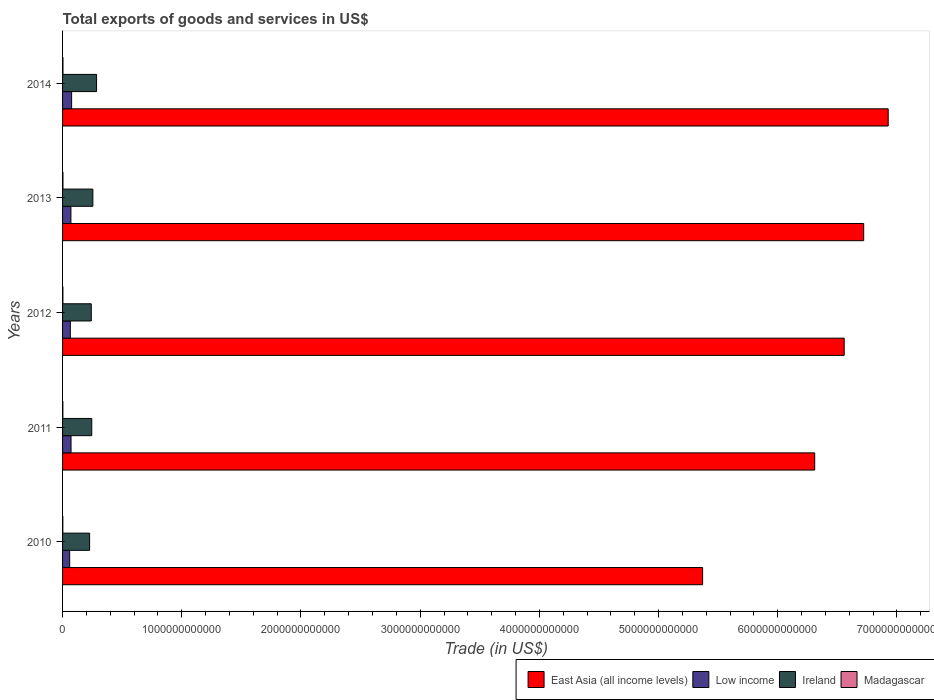How many different coloured bars are there?
Give a very brief answer. 4. How many groups of bars are there?
Give a very brief answer. 5. How many bars are there on the 3rd tick from the bottom?
Make the answer very short. 4. What is the label of the 2nd group of bars from the top?
Offer a terse response. 2013. What is the total exports of goods and services in Madagascar in 2012?
Provide a short and direct response. 2.88e+09. Across all years, what is the maximum total exports of goods and services in Low income?
Make the answer very short. 7.59e+1. Across all years, what is the minimum total exports of goods and services in Low income?
Provide a short and direct response. 5.96e+1. In which year was the total exports of goods and services in Low income maximum?
Provide a short and direct response. 2014. What is the total total exports of goods and services in Low income in the graph?
Offer a terse response. 3.42e+11. What is the difference between the total exports of goods and services in East Asia (all income levels) in 2010 and that in 2013?
Give a very brief answer. -1.35e+12. What is the difference between the total exports of goods and services in Ireland in 2011 and the total exports of goods and services in Low income in 2014?
Ensure brevity in your answer.  1.69e+11. What is the average total exports of goods and services in Ireland per year?
Give a very brief answer. 2.50e+11. In the year 2011, what is the difference between the total exports of goods and services in East Asia (all income levels) and total exports of goods and services in Madagascar?
Provide a short and direct response. 6.31e+12. In how many years, is the total exports of goods and services in Madagascar greater than 5600000000000 US$?
Your answer should be very brief. 0. What is the ratio of the total exports of goods and services in East Asia (all income levels) in 2010 to that in 2011?
Make the answer very short. 0.85. What is the difference between the highest and the second highest total exports of goods and services in Low income?
Your answer should be very brief. 4.85e+09. What is the difference between the highest and the lowest total exports of goods and services in Ireland?
Provide a succinct answer. 5.83e+1. In how many years, is the total exports of goods and services in Ireland greater than the average total exports of goods and services in Ireland taken over all years?
Offer a terse response. 2. Is it the case that in every year, the sum of the total exports of goods and services in Madagascar and total exports of goods and services in Ireland is greater than the sum of total exports of goods and services in East Asia (all income levels) and total exports of goods and services in Low income?
Make the answer very short. Yes. What does the 2nd bar from the top in 2014 represents?
Keep it short and to the point. Ireland. What does the 4th bar from the bottom in 2010 represents?
Give a very brief answer. Madagascar. How many bars are there?
Give a very brief answer. 20. What is the difference between two consecutive major ticks on the X-axis?
Provide a succinct answer. 1.00e+12. Are the values on the major ticks of X-axis written in scientific E-notation?
Your answer should be compact. No. Does the graph contain any zero values?
Keep it short and to the point. No. Does the graph contain grids?
Your answer should be compact. No. How are the legend labels stacked?
Keep it short and to the point. Horizontal. What is the title of the graph?
Make the answer very short. Total exports of goods and services in US$. What is the label or title of the X-axis?
Give a very brief answer. Trade (in US$). What is the label or title of the Y-axis?
Make the answer very short. Years. What is the Trade (in US$) in East Asia (all income levels) in 2010?
Provide a short and direct response. 5.37e+12. What is the Trade (in US$) in Low income in 2010?
Your answer should be very brief. 5.96e+1. What is the Trade (in US$) of Ireland in 2010?
Your response must be concise. 2.27e+11. What is the Trade (in US$) in Madagascar in 2010?
Provide a short and direct response. 2.18e+09. What is the Trade (in US$) of East Asia (all income levels) in 2011?
Your answer should be compact. 6.31e+12. What is the Trade (in US$) in Low income in 2011?
Ensure brevity in your answer.  7.11e+1. What is the Trade (in US$) of Ireland in 2011?
Your answer should be compact. 2.45e+11. What is the Trade (in US$) in Madagascar in 2011?
Offer a terse response. 2.65e+09. What is the Trade (in US$) of East Asia (all income levels) in 2012?
Your response must be concise. 6.56e+12. What is the Trade (in US$) of Low income in 2012?
Make the answer very short. 6.50e+1. What is the Trade (in US$) of Ireland in 2012?
Ensure brevity in your answer.  2.41e+11. What is the Trade (in US$) in Madagascar in 2012?
Give a very brief answer. 2.88e+09. What is the Trade (in US$) of East Asia (all income levels) in 2013?
Offer a very short reply. 6.72e+12. What is the Trade (in US$) in Low income in 2013?
Your answer should be very brief. 7.01e+1. What is the Trade (in US$) in Ireland in 2013?
Your response must be concise. 2.54e+11. What is the Trade (in US$) of Madagascar in 2013?
Offer a terse response. 3.19e+09. What is the Trade (in US$) in East Asia (all income levels) in 2014?
Your response must be concise. 6.93e+12. What is the Trade (in US$) in Low income in 2014?
Provide a succinct answer. 7.59e+1. What is the Trade (in US$) of Ireland in 2014?
Your response must be concise. 2.85e+11. What is the Trade (in US$) of Madagascar in 2014?
Make the answer very short. 3.37e+09. Across all years, what is the maximum Trade (in US$) of East Asia (all income levels)?
Your response must be concise. 6.93e+12. Across all years, what is the maximum Trade (in US$) of Low income?
Your response must be concise. 7.59e+1. Across all years, what is the maximum Trade (in US$) of Ireland?
Ensure brevity in your answer.  2.85e+11. Across all years, what is the maximum Trade (in US$) in Madagascar?
Provide a short and direct response. 3.37e+09. Across all years, what is the minimum Trade (in US$) in East Asia (all income levels)?
Keep it short and to the point. 5.37e+12. Across all years, what is the minimum Trade (in US$) of Low income?
Your answer should be very brief. 5.96e+1. Across all years, what is the minimum Trade (in US$) of Ireland?
Offer a terse response. 2.27e+11. Across all years, what is the minimum Trade (in US$) in Madagascar?
Make the answer very short. 2.18e+09. What is the total Trade (in US$) of East Asia (all income levels) in the graph?
Ensure brevity in your answer.  3.19e+13. What is the total Trade (in US$) of Low income in the graph?
Make the answer very short. 3.42e+11. What is the total Trade (in US$) of Ireland in the graph?
Your answer should be very brief. 1.25e+12. What is the total Trade (in US$) of Madagascar in the graph?
Offer a very short reply. 1.43e+1. What is the difference between the Trade (in US$) of East Asia (all income levels) in 2010 and that in 2011?
Offer a very short reply. -9.40e+11. What is the difference between the Trade (in US$) in Low income in 2010 and that in 2011?
Offer a terse response. -1.15e+1. What is the difference between the Trade (in US$) in Ireland in 2010 and that in 2011?
Offer a very short reply. -1.79e+1. What is the difference between the Trade (in US$) in Madagascar in 2010 and that in 2011?
Ensure brevity in your answer.  -4.65e+08. What is the difference between the Trade (in US$) of East Asia (all income levels) in 2010 and that in 2012?
Make the answer very short. -1.19e+12. What is the difference between the Trade (in US$) in Low income in 2010 and that in 2012?
Keep it short and to the point. -5.43e+09. What is the difference between the Trade (in US$) of Ireland in 2010 and that in 2012?
Provide a succinct answer. -1.39e+1. What is the difference between the Trade (in US$) of Madagascar in 2010 and that in 2012?
Provide a succinct answer. -6.98e+08. What is the difference between the Trade (in US$) in East Asia (all income levels) in 2010 and that in 2013?
Provide a succinct answer. -1.35e+12. What is the difference between the Trade (in US$) of Low income in 2010 and that in 2013?
Your answer should be very brief. -1.06e+1. What is the difference between the Trade (in US$) in Ireland in 2010 and that in 2013?
Ensure brevity in your answer.  -2.72e+1. What is the difference between the Trade (in US$) in Madagascar in 2010 and that in 2013?
Your response must be concise. -1.01e+09. What is the difference between the Trade (in US$) of East Asia (all income levels) in 2010 and that in 2014?
Provide a succinct answer. -1.56e+12. What is the difference between the Trade (in US$) in Low income in 2010 and that in 2014?
Offer a very short reply. -1.64e+1. What is the difference between the Trade (in US$) of Ireland in 2010 and that in 2014?
Provide a succinct answer. -5.83e+1. What is the difference between the Trade (in US$) of Madagascar in 2010 and that in 2014?
Offer a terse response. -1.19e+09. What is the difference between the Trade (in US$) of East Asia (all income levels) in 2011 and that in 2012?
Offer a very short reply. -2.48e+11. What is the difference between the Trade (in US$) in Low income in 2011 and that in 2012?
Keep it short and to the point. 6.09e+09. What is the difference between the Trade (in US$) of Ireland in 2011 and that in 2012?
Your response must be concise. 3.99e+09. What is the difference between the Trade (in US$) of Madagascar in 2011 and that in 2012?
Provide a succinct answer. -2.32e+08. What is the difference between the Trade (in US$) in East Asia (all income levels) in 2011 and that in 2013?
Provide a short and direct response. -4.11e+11. What is the difference between the Trade (in US$) in Low income in 2011 and that in 2013?
Your answer should be compact. 9.62e+08. What is the difference between the Trade (in US$) of Ireland in 2011 and that in 2013?
Your response must be concise. -9.37e+09. What is the difference between the Trade (in US$) in Madagascar in 2011 and that in 2013?
Offer a very short reply. -5.46e+08. What is the difference between the Trade (in US$) in East Asia (all income levels) in 2011 and that in 2014?
Provide a short and direct response. -6.17e+11. What is the difference between the Trade (in US$) in Low income in 2011 and that in 2014?
Provide a succinct answer. -4.85e+09. What is the difference between the Trade (in US$) of Ireland in 2011 and that in 2014?
Provide a short and direct response. -4.04e+1. What is the difference between the Trade (in US$) of Madagascar in 2011 and that in 2014?
Offer a terse response. -7.27e+08. What is the difference between the Trade (in US$) in East Asia (all income levels) in 2012 and that in 2013?
Offer a terse response. -1.64e+11. What is the difference between the Trade (in US$) of Low income in 2012 and that in 2013?
Make the answer very short. -5.12e+09. What is the difference between the Trade (in US$) in Ireland in 2012 and that in 2013?
Your response must be concise. -1.34e+1. What is the difference between the Trade (in US$) in Madagascar in 2012 and that in 2013?
Give a very brief answer. -3.13e+08. What is the difference between the Trade (in US$) of East Asia (all income levels) in 2012 and that in 2014?
Make the answer very short. -3.69e+11. What is the difference between the Trade (in US$) in Low income in 2012 and that in 2014?
Make the answer very short. -1.09e+1. What is the difference between the Trade (in US$) of Ireland in 2012 and that in 2014?
Your answer should be very brief. -4.44e+1. What is the difference between the Trade (in US$) of Madagascar in 2012 and that in 2014?
Provide a short and direct response. -4.95e+08. What is the difference between the Trade (in US$) in East Asia (all income levels) in 2013 and that in 2014?
Offer a terse response. -2.06e+11. What is the difference between the Trade (in US$) of Low income in 2013 and that in 2014?
Offer a very short reply. -5.82e+09. What is the difference between the Trade (in US$) of Ireland in 2013 and that in 2014?
Your response must be concise. -3.10e+1. What is the difference between the Trade (in US$) of Madagascar in 2013 and that in 2014?
Give a very brief answer. -1.82e+08. What is the difference between the Trade (in US$) of East Asia (all income levels) in 2010 and the Trade (in US$) of Low income in 2011?
Ensure brevity in your answer.  5.30e+12. What is the difference between the Trade (in US$) in East Asia (all income levels) in 2010 and the Trade (in US$) in Ireland in 2011?
Provide a short and direct response. 5.12e+12. What is the difference between the Trade (in US$) in East Asia (all income levels) in 2010 and the Trade (in US$) in Madagascar in 2011?
Your answer should be compact. 5.37e+12. What is the difference between the Trade (in US$) of Low income in 2010 and the Trade (in US$) of Ireland in 2011?
Provide a succinct answer. -1.85e+11. What is the difference between the Trade (in US$) in Low income in 2010 and the Trade (in US$) in Madagascar in 2011?
Provide a short and direct response. 5.69e+1. What is the difference between the Trade (in US$) of Ireland in 2010 and the Trade (in US$) of Madagascar in 2011?
Provide a succinct answer. 2.24e+11. What is the difference between the Trade (in US$) of East Asia (all income levels) in 2010 and the Trade (in US$) of Low income in 2012?
Make the answer very short. 5.30e+12. What is the difference between the Trade (in US$) in East Asia (all income levels) in 2010 and the Trade (in US$) in Ireland in 2012?
Provide a short and direct response. 5.13e+12. What is the difference between the Trade (in US$) in East Asia (all income levels) in 2010 and the Trade (in US$) in Madagascar in 2012?
Give a very brief answer. 5.37e+12. What is the difference between the Trade (in US$) of Low income in 2010 and the Trade (in US$) of Ireland in 2012?
Your answer should be very brief. -1.81e+11. What is the difference between the Trade (in US$) of Low income in 2010 and the Trade (in US$) of Madagascar in 2012?
Offer a terse response. 5.67e+1. What is the difference between the Trade (in US$) of Ireland in 2010 and the Trade (in US$) of Madagascar in 2012?
Your answer should be very brief. 2.24e+11. What is the difference between the Trade (in US$) in East Asia (all income levels) in 2010 and the Trade (in US$) in Low income in 2013?
Ensure brevity in your answer.  5.30e+12. What is the difference between the Trade (in US$) of East Asia (all income levels) in 2010 and the Trade (in US$) of Ireland in 2013?
Make the answer very short. 5.12e+12. What is the difference between the Trade (in US$) in East Asia (all income levels) in 2010 and the Trade (in US$) in Madagascar in 2013?
Offer a terse response. 5.37e+12. What is the difference between the Trade (in US$) in Low income in 2010 and the Trade (in US$) in Ireland in 2013?
Ensure brevity in your answer.  -1.95e+11. What is the difference between the Trade (in US$) in Low income in 2010 and the Trade (in US$) in Madagascar in 2013?
Offer a terse response. 5.64e+1. What is the difference between the Trade (in US$) in Ireland in 2010 and the Trade (in US$) in Madagascar in 2013?
Your answer should be very brief. 2.24e+11. What is the difference between the Trade (in US$) in East Asia (all income levels) in 2010 and the Trade (in US$) in Low income in 2014?
Your response must be concise. 5.29e+12. What is the difference between the Trade (in US$) of East Asia (all income levels) in 2010 and the Trade (in US$) of Ireland in 2014?
Your response must be concise. 5.08e+12. What is the difference between the Trade (in US$) in East Asia (all income levels) in 2010 and the Trade (in US$) in Madagascar in 2014?
Your response must be concise. 5.37e+12. What is the difference between the Trade (in US$) of Low income in 2010 and the Trade (in US$) of Ireland in 2014?
Make the answer very short. -2.26e+11. What is the difference between the Trade (in US$) in Low income in 2010 and the Trade (in US$) in Madagascar in 2014?
Ensure brevity in your answer.  5.62e+1. What is the difference between the Trade (in US$) in Ireland in 2010 and the Trade (in US$) in Madagascar in 2014?
Give a very brief answer. 2.24e+11. What is the difference between the Trade (in US$) of East Asia (all income levels) in 2011 and the Trade (in US$) of Low income in 2012?
Ensure brevity in your answer.  6.25e+12. What is the difference between the Trade (in US$) in East Asia (all income levels) in 2011 and the Trade (in US$) in Ireland in 2012?
Your answer should be very brief. 6.07e+12. What is the difference between the Trade (in US$) of East Asia (all income levels) in 2011 and the Trade (in US$) of Madagascar in 2012?
Offer a terse response. 6.31e+12. What is the difference between the Trade (in US$) in Low income in 2011 and the Trade (in US$) in Ireland in 2012?
Provide a short and direct response. -1.70e+11. What is the difference between the Trade (in US$) of Low income in 2011 and the Trade (in US$) of Madagascar in 2012?
Ensure brevity in your answer.  6.82e+1. What is the difference between the Trade (in US$) of Ireland in 2011 and the Trade (in US$) of Madagascar in 2012?
Give a very brief answer. 2.42e+11. What is the difference between the Trade (in US$) in East Asia (all income levels) in 2011 and the Trade (in US$) in Low income in 2013?
Provide a short and direct response. 6.24e+12. What is the difference between the Trade (in US$) of East Asia (all income levels) in 2011 and the Trade (in US$) of Ireland in 2013?
Make the answer very short. 6.06e+12. What is the difference between the Trade (in US$) in East Asia (all income levels) in 2011 and the Trade (in US$) in Madagascar in 2013?
Make the answer very short. 6.31e+12. What is the difference between the Trade (in US$) in Low income in 2011 and the Trade (in US$) in Ireland in 2013?
Your response must be concise. -1.83e+11. What is the difference between the Trade (in US$) of Low income in 2011 and the Trade (in US$) of Madagascar in 2013?
Your response must be concise. 6.79e+1. What is the difference between the Trade (in US$) of Ireland in 2011 and the Trade (in US$) of Madagascar in 2013?
Ensure brevity in your answer.  2.42e+11. What is the difference between the Trade (in US$) in East Asia (all income levels) in 2011 and the Trade (in US$) in Low income in 2014?
Keep it short and to the point. 6.23e+12. What is the difference between the Trade (in US$) in East Asia (all income levels) in 2011 and the Trade (in US$) in Ireland in 2014?
Provide a succinct answer. 6.02e+12. What is the difference between the Trade (in US$) of East Asia (all income levels) in 2011 and the Trade (in US$) of Madagascar in 2014?
Give a very brief answer. 6.31e+12. What is the difference between the Trade (in US$) of Low income in 2011 and the Trade (in US$) of Ireland in 2014?
Keep it short and to the point. -2.14e+11. What is the difference between the Trade (in US$) of Low income in 2011 and the Trade (in US$) of Madagascar in 2014?
Make the answer very short. 6.77e+1. What is the difference between the Trade (in US$) of Ireland in 2011 and the Trade (in US$) of Madagascar in 2014?
Offer a very short reply. 2.41e+11. What is the difference between the Trade (in US$) in East Asia (all income levels) in 2012 and the Trade (in US$) in Low income in 2013?
Your answer should be very brief. 6.49e+12. What is the difference between the Trade (in US$) of East Asia (all income levels) in 2012 and the Trade (in US$) of Ireland in 2013?
Your answer should be very brief. 6.30e+12. What is the difference between the Trade (in US$) of East Asia (all income levels) in 2012 and the Trade (in US$) of Madagascar in 2013?
Offer a terse response. 6.55e+12. What is the difference between the Trade (in US$) in Low income in 2012 and the Trade (in US$) in Ireland in 2013?
Provide a succinct answer. -1.89e+11. What is the difference between the Trade (in US$) of Low income in 2012 and the Trade (in US$) of Madagascar in 2013?
Your answer should be very brief. 6.18e+1. What is the difference between the Trade (in US$) of Ireland in 2012 and the Trade (in US$) of Madagascar in 2013?
Keep it short and to the point. 2.38e+11. What is the difference between the Trade (in US$) of East Asia (all income levels) in 2012 and the Trade (in US$) of Low income in 2014?
Ensure brevity in your answer.  6.48e+12. What is the difference between the Trade (in US$) of East Asia (all income levels) in 2012 and the Trade (in US$) of Ireland in 2014?
Offer a very short reply. 6.27e+12. What is the difference between the Trade (in US$) of East Asia (all income levels) in 2012 and the Trade (in US$) of Madagascar in 2014?
Your response must be concise. 6.55e+12. What is the difference between the Trade (in US$) in Low income in 2012 and the Trade (in US$) in Ireland in 2014?
Ensure brevity in your answer.  -2.20e+11. What is the difference between the Trade (in US$) in Low income in 2012 and the Trade (in US$) in Madagascar in 2014?
Your answer should be compact. 6.16e+1. What is the difference between the Trade (in US$) of Ireland in 2012 and the Trade (in US$) of Madagascar in 2014?
Your response must be concise. 2.37e+11. What is the difference between the Trade (in US$) of East Asia (all income levels) in 2013 and the Trade (in US$) of Low income in 2014?
Make the answer very short. 6.65e+12. What is the difference between the Trade (in US$) of East Asia (all income levels) in 2013 and the Trade (in US$) of Ireland in 2014?
Your answer should be very brief. 6.44e+12. What is the difference between the Trade (in US$) in East Asia (all income levels) in 2013 and the Trade (in US$) in Madagascar in 2014?
Keep it short and to the point. 6.72e+12. What is the difference between the Trade (in US$) of Low income in 2013 and the Trade (in US$) of Ireland in 2014?
Your response must be concise. -2.15e+11. What is the difference between the Trade (in US$) in Low income in 2013 and the Trade (in US$) in Madagascar in 2014?
Make the answer very short. 6.67e+1. What is the difference between the Trade (in US$) of Ireland in 2013 and the Trade (in US$) of Madagascar in 2014?
Keep it short and to the point. 2.51e+11. What is the average Trade (in US$) of East Asia (all income levels) per year?
Keep it short and to the point. 6.38e+12. What is the average Trade (in US$) of Low income per year?
Give a very brief answer. 6.83e+1. What is the average Trade (in US$) of Ireland per year?
Your response must be concise. 2.50e+11. What is the average Trade (in US$) of Madagascar per year?
Offer a terse response. 2.85e+09. In the year 2010, what is the difference between the Trade (in US$) in East Asia (all income levels) and Trade (in US$) in Low income?
Your response must be concise. 5.31e+12. In the year 2010, what is the difference between the Trade (in US$) in East Asia (all income levels) and Trade (in US$) in Ireland?
Keep it short and to the point. 5.14e+12. In the year 2010, what is the difference between the Trade (in US$) in East Asia (all income levels) and Trade (in US$) in Madagascar?
Your answer should be compact. 5.37e+12. In the year 2010, what is the difference between the Trade (in US$) of Low income and Trade (in US$) of Ireland?
Give a very brief answer. -1.67e+11. In the year 2010, what is the difference between the Trade (in US$) of Low income and Trade (in US$) of Madagascar?
Your response must be concise. 5.74e+1. In the year 2010, what is the difference between the Trade (in US$) of Ireland and Trade (in US$) of Madagascar?
Your response must be concise. 2.25e+11. In the year 2011, what is the difference between the Trade (in US$) of East Asia (all income levels) and Trade (in US$) of Low income?
Offer a terse response. 6.24e+12. In the year 2011, what is the difference between the Trade (in US$) of East Asia (all income levels) and Trade (in US$) of Ireland?
Give a very brief answer. 6.07e+12. In the year 2011, what is the difference between the Trade (in US$) in East Asia (all income levels) and Trade (in US$) in Madagascar?
Offer a very short reply. 6.31e+12. In the year 2011, what is the difference between the Trade (in US$) in Low income and Trade (in US$) in Ireland?
Provide a short and direct response. -1.74e+11. In the year 2011, what is the difference between the Trade (in US$) in Low income and Trade (in US$) in Madagascar?
Offer a very short reply. 6.84e+1. In the year 2011, what is the difference between the Trade (in US$) of Ireland and Trade (in US$) of Madagascar?
Your response must be concise. 2.42e+11. In the year 2012, what is the difference between the Trade (in US$) in East Asia (all income levels) and Trade (in US$) in Low income?
Give a very brief answer. 6.49e+12. In the year 2012, what is the difference between the Trade (in US$) of East Asia (all income levels) and Trade (in US$) of Ireland?
Provide a short and direct response. 6.32e+12. In the year 2012, what is the difference between the Trade (in US$) in East Asia (all income levels) and Trade (in US$) in Madagascar?
Your response must be concise. 6.55e+12. In the year 2012, what is the difference between the Trade (in US$) in Low income and Trade (in US$) in Ireland?
Keep it short and to the point. -1.76e+11. In the year 2012, what is the difference between the Trade (in US$) in Low income and Trade (in US$) in Madagascar?
Offer a very short reply. 6.21e+1. In the year 2012, what is the difference between the Trade (in US$) of Ireland and Trade (in US$) of Madagascar?
Your answer should be very brief. 2.38e+11. In the year 2013, what is the difference between the Trade (in US$) in East Asia (all income levels) and Trade (in US$) in Low income?
Your answer should be compact. 6.65e+12. In the year 2013, what is the difference between the Trade (in US$) in East Asia (all income levels) and Trade (in US$) in Ireland?
Offer a terse response. 6.47e+12. In the year 2013, what is the difference between the Trade (in US$) in East Asia (all income levels) and Trade (in US$) in Madagascar?
Make the answer very short. 6.72e+12. In the year 2013, what is the difference between the Trade (in US$) of Low income and Trade (in US$) of Ireland?
Offer a terse response. -1.84e+11. In the year 2013, what is the difference between the Trade (in US$) of Low income and Trade (in US$) of Madagascar?
Your answer should be very brief. 6.69e+1. In the year 2013, what is the difference between the Trade (in US$) in Ireland and Trade (in US$) in Madagascar?
Ensure brevity in your answer.  2.51e+11. In the year 2014, what is the difference between the Trade (in US$) of East Asia (all income levels) and Trade (in US$) of Low income?
Make the answer very short. 6.85e+12. In the year 2014, what is the difference between the Trade (in US$) of East Asia (all income levels) and Trade (in US$) of Ireland?
Your answer should be very brief. 6.64e+12. In the year 2014, what is the difference between the Trade (in US$) in East Asia (all income levels) and Trade (in US$) in Madagascar?
Give a very brief answer. 6.92e+12. In the year 2014, what is the difference between the Trade (in US$) in Low income and Trade (in US$) in Ireland?
Provide a succinct answer. -2.09e+11. In the year 2014, what is the difference between the Trade (in US$) of Low income and Trade (in US$) of Madagascar?
Provide a short and direct response. 7.26e+1. In the year 2014, what is the difference between the Trade (in US$) in Ireland and Trade (in US$) in Madagascar?
Ensure brevity in your answer.  2.82e+11. What is the ratio of the Trade (in US$) in East Asia (all income levels) in 2010 to that in 2011?
Give a very brief answer. 0.85. What is the ratio of the Trade (in US$) in Low income in 2010 to that in 2011?
Keep it short and to the point. 0.84. What is the ratio of the Trade (in US$) of Ireland in 2010 to that in 2011?
Provide a short and direct response. 0.93. What is the ratio of the Trade (in US$) of Madagascar in 2010 to that in 2011?
Offer a very short reply. 0.82. What is the ratio of the Trade (in US$) in East Asia (all income levels) in 2010 to that in 2012?
Your answer should be compact. 0.82. What is the ratio of the Trade (in US$) in Low income in 2010 to that in 2012?
Your answer should be compact. 0.92. What is the ratio of the Trade (in US$) of Ireland in 2010 to that in 2012?
Give a very brief answer. 0.94. What is the ratio of the Trade (in US$) of Madagascar in 2010 to that in 2012?
Provide a succinct answer. 0.76. What is the ratio of the Trade (in US$) of East Asia (all income levels) in 2010 to that in 2013?
Your answer should be compact. 0.8. What is the ratio of the Trade (in US$) in Low income in 2010 to that in 2013?
Your answer should be compact. 0.85. What is the ratio of the Trade (in US$) in Ireland in 2010 to that in 2013?
Provide a short and direct response. 0.89. What is the ratio of the Trade (in US$) of Madagascar in 2010 to that in 2013?
Provide a succinct answer. 0.68. What is the ratio of the Trade (in US$) in East Asia (all income levels) in 2010 to that in 2014?
Offer a terse response. 0.78. What is the ratio of the Trade (in US$) in Low income in 2010 to that in 2014?
Make the answer very short. 0.78. What is the ratio of the Trade (in US$) of Ireland in 2010 to that in 2014?
Your answer should be very brief. 0.8. What is the ratio of the Trade (in US$) in Madagascar in 2010 to that in 2014?
Provide a short and direct response. 0.65. What is the ratio of the Trade (in US$) in East Asia (all income levels) in 2011 to that in 2012?
Offer a terse response. 0.96. What is the ratio of the Trade (in US$) in Low income in 2011 to that in 2012?
Your answer should be very brief. 1.09. What is the ratio of the Trade (in US$) of Ireland in 2011 to that in 2012?
Offer a terse response. 1.02. What is the ratio of the Trade (in US$) of Madagascar in 2011 to that in 2012?
Provide a succinct answer. 0.92. What is the ratio of the Trade (in US$) in East Asia (all income levels) in 2011 to that in 2013?
Offer a terse response. 0.94. What is the ratio of the Trade (in US$) in Low income in 2011 to that in 2013?
Provide a succinct answer. 1.01. What is the ratio of the Trade (in US$) of Ireland in 2011 to that in 2013?
Ensure brevity in your answer.  0.96. What is the ratio of the Trade (in US$) of Madagascar in 2011 to that in 2013?
Your answer should be very brief. 0.83. What is the ratio of the Trade (in US$) of East Asia (all income levels) in 2011 to that in 2014?
Give a very brief answer. 0.91. What is the ratio of the Trade (in US$) in Low income in 2011 to that in 2014?
Your answer should be compact. 0.94. What is the ratio of the Trade (in US$) in Ireland in 2011 to that in 2014?
Offer a terse response. 0.86. What is the ratio of the Trade (in US$) in Madagascar in 2011 to that in 2014?
Offer a terse response. 0.78. What is the ratio of the Trade (in US$) of East Asia (all income levels) in 2012 to that in 2013?
Provide a short and direct response. 0.98. What is the ratio of the Trade (in US$) of Low income in 2012 to that in 2013?
Provide a short and direct response. 0.93. What is the ratio of the Trade (in US$) in Ireland in 2012 to that in 2013?
Give a very brief answer. 0.95. What is the ratio of the Trade (in US$) in Madagascar in 2012 to that in 2013?
Offer a very short reply. 0.9. What is the ratio of the Trade (in US$) of East Asia (all income levels) in 2012 to that in 2014?
Your response must be concise. 0.95. What is the ratio of the Trade (in US$) of Low income in 2012 to that in 2014?
Offer a very short reply. 0.86. What is the ratio of the Trade (in US$) of Ireland in 2012 to that in 2014?
Provide a succinct answer. 0.84. What is the ratio of the Trade (in US$) of Madagascar in 2012 to that in 2014?
Offer a terse response. 0.85. What is the ratio of the Trade (in US$) of East Asia (all income levels) in 2013 to that in 2014?
Offer a very short reply. 0.97. What is the ratio of the Trade (in US$) in Low income in 2013 to that in 2014?
Offer a very short reply. 0.92. What is the ratio of the Trade (in US$) of Ireland in 2013 to that in 2014?
Offer a terse response. 0.89. What is the ratio of the Trade (in US$) in Madagascar in 2013 to that in 2014?
Make the answer very short. 0.95. What is the difference between the highest and the second highest Trade (in US$) in East Asia (all income levels)?
Offer a very short reply. 2.06e+11. What is the difference between the highest and the second highest Trade (in US$) of Low income?
Offer a very short reply. 4.85e+09. What is the difference between the highest and the second highest Trade (in US$) of Ireland?
Make the answer very short. 3.10e+1. What is the difference between the highest and the second highest Trade (in US$) in Madagascar?
Keep it short and to the point. 1.82e+08. What is the difference between the highest and the lowest Trade (in US$) of East Asia (all income levels)?
Ensure brevity in your answer.  1.56e+12. What is the difference between the highest and the lowest Trade (in US$) in Low income?
Offer a very short reply. 1.64e+1. What is the difference between the highest and the lowest Trade (in US$) in Ireland?
Your response must be concise. 5.83e+1. What is the difference between the highest and the lowest Trade (in US$) in Madagascar?
Give a very brief answer. 1.19e+09. 